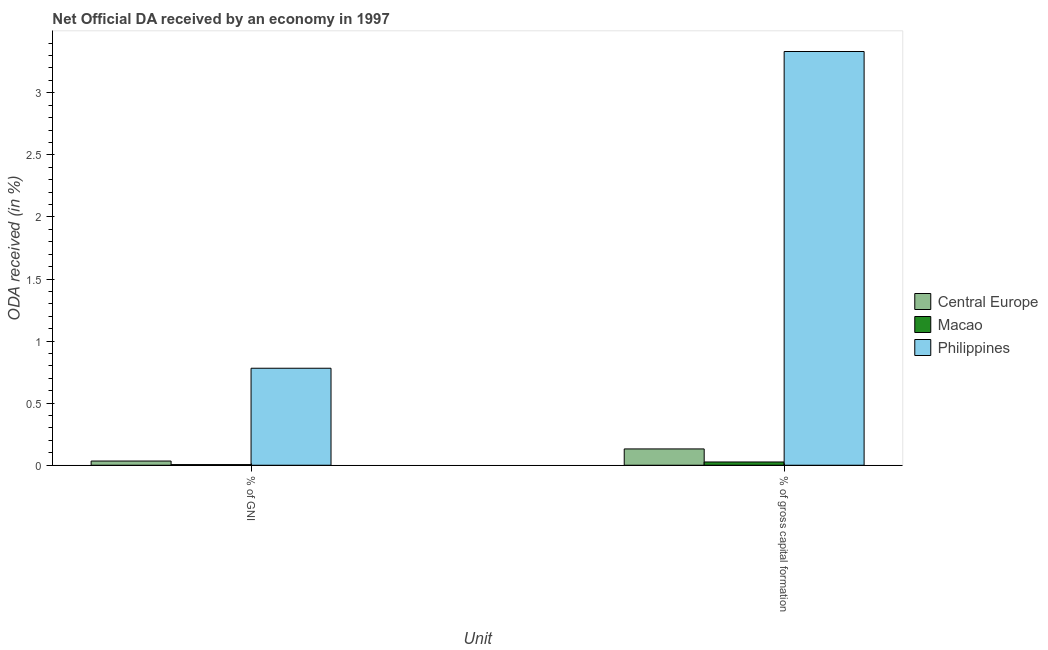How many different coloured bars are there?
Ensure brevity in your answer.  3. Are the number of bars per tick equal to the number of legend labels?
Offer a very short reply. Yes. Are the number of bars on each tick of the X-axis equal?
Offer a terse response. Yes. How many bars are there on the 2nd tick from the right?
Offer a terse response. 3. What is the label of the 1st group of bars from the left?
Keep it short and to the point. % of GNI. What is the oda received as percentage of gni in Philippines?
Provide a short and direct response. 0.78. Across all countries, what is the maximum oda received as percentage of gross capital formation?
Your answer should be compact. 3.33. Across all countries, what is the minimum oda received as percentage of gni?
Provide a short and direct response. 0.01. In which country was the oda received as percentage of gross capital formation maximum?
Make the answer very short. Philippines. In which country was the oda received as percentage of gni minimum?
Ensure brevity in your answer.  Macao. What is the total oda received as percentage of gni in the graph?
Provide a short and direct response. 0.82. What is the difference between the oda received as percentage of gross capital formation in Central Europe and that in Macao?
Your answer should be compact. 0.11. What is the difference between the oda received as percentage of gross capital formation in Central Europe and the oda received as percentage of gni in Philippines?
Your answer should be very brief. -0.65. What is the average oda received as percentage of gross capital formation per country?
Your answer should be very brief. 1.16. What is the difference between the oda received as percentage of gross capital formation and oda received as percentage of gni in Central Europe?
Provide a short and direct response. 0.1. What is the ratio of the oda received as percentage of gni in Macao to that in Philippines?
Your response must be concise. 0.01. Is the oda received as percentage of gross capital formation in Philippines less than that in Macao?
Your answer should be compact. No. What does the 1st bar from the left in % of gross capital formation represents?
Offer a terse response. Central Europe. What does the 1st bar from the right in % of GNI represents?
Offer a very short reply. Philippines. How many countries are there in the graph?
Provide a succinct answer. 3. What is the difference between two consecutive major ticks on the Y-axis?
Your answer should be compact. 0.5. Does the graph contain any zero values?
Keep it short and to the point. No. Where does the legend appear in the graph?
Make the answer very short. Center right. What is the title of the graph?
Your answer should be compact. Net Official DA received by an economy in 1997. Does "World" appear as one of the legend labels in the graph?
Keep it short and to the point. No. What is the label or title of the X-axis?
Offer a terse response. Unit. What is the label or title of the Y-axis?
Keep it short and to the point. ODA received (in %). What is the ODA received (in %) of Central Europe in % of GNI?
Give a very brief answer. 0.03. What is the ODA received (in %) of Macao in % of GNI?
Ensure brevity in your answer.  0.01. What is the ODA received (in %) in Philippines in % of GNI?
Your response must be concise. 0.78. What is the ODA received (in %) in Central Europe in % of gross capital formation?
Offer a terse response. 0.13. What is the ODA received (in %) in Macao in % of gross capital formation?
Ensure brevity in your answer.  0.03. What is the ODA received (in %) of Philippines in % of gross capital formation?
Your answer should be compact. 3.33. Across all Unit, what is the maximum ODA received (in %) in Central Europe?
Offer a very short reply. 0.13. Across all Unit, what is the maximum ODA received (in %) in Macao?
Give a very brief answer. 0.03. Across all Unit, what is the maximum ODA received (in %) in Philippines?
Your response must be concise. 3.33. Across all Unit, what is the minimum ODA received (in %) in Central Europe?
Give a very brief answer. 0.03. Across all Unit, what is the minimum ODA received (in %) in Macao?
Your answer should be very brief. 0.01. Across all Unit, what is the minimum ODA received (in %) of Philippines?
Provide a short and direct response. 0.78. What is the total ODA received (in %) in Central Europe in the graph?
Your answer should be compact. 0.17. What is the total ODA received (in %) of Macao in the graph?
Ensure brevity in your answer.  0.03. What is the total ODA received (in %) in Philippines in the graph?
Offer a terse response. 4.11. What is the difference between the ODA received (in %) in Central Europe in % of GNI and that in % of gross capital formation?
Your response must be concise. -0.1. What is the difference between the ODA received (in %) of Macao in % of GNI and that in % of gross capital formation?
Offer a terse response. -0.02. What is the difference between the ODA received (in %) of Philippines in % of GNI and that in % of gross capital formation?
Provide a short and direct response. -2.55. What is the difference between the ODA received (in %) in Central Europe in % of GNI and the ODA received (in %) in Macao in % of gross capital formation?
Your response must be concise. 0.01. What is the difference between the ODA received (in %) of Central Europe in % of GNI and the ODA received (in %) of Philippines in % of gross capital formation?
Provide a succinct answer. -3.3. What is the difference between the ODA received (in %) in Macao in % of GNI and the ODA received (in %) in Philippines in % of gross capital formation?
Offer a very short reply. -3.33. What is the average ODA received (in %) of Central Europe per Unit?
Give a very brief answer. 0.08. What is the average ODA received (in %) in Macao per Unit?
Provide a short and direct response. 0.02. What is the average ODA received (in %) in Philippines per Unit?
Ensure brevity in your answer.  2.06. What is the difference between the ODA received (in %) of Central Europe and ODA received (in %) of Macao in % of GNI?
Provide a succinct answer. 0.03. What is the difference between the ODA received (in %) in Central Europe and ODA received (in %) in Philippines in % of GNI?
Give a very brief answer. -0.75. What is the difference between the ODA received (in %) of Macao and ODA received (in %) of Philippines in % of GNI?
Your answer should be very brief. -0.78. What is the difference between the ODA received (in %) in Central Europe and ODA received (in %) in Macao in % of gross capital formation?
Provide a short and direct response. 0.11. What is the difference between the ODA received (in %) in Central Europe and ODA received (in %) in Philippines in % of gross capital formation?
Make the answer very short. -3.2. What is the difference between the ODA received (in %) in Macao and ODA received (in %) in Philippines in % of gross capital formation?
Your answer should be compact. -3.31. What is the ratio of the ODA received (in %) in Central Europe in % of GNI to that in % of gross capital formation?
Your answer should be compact. 0.26. What is the ratio of the ODA received (in %) in Macao in % of GNI to that in % of gross capital formation?
Make the answer very short. 0.2. What is the ratio of the ODA received (in %) in Philippines in % of GNI to that in % of gross capital formation?
Provide a succinct answer. 0.23. What is the difference between the highest and the second highest ODA received (in %) in Central Europe?
Give a very brief answer. 0.1. What is the difference between the highest and the second highest ODA received (in %) of Macao?
Ensure brevity in your answer.  0.02. What is the difference between the highest and the second highest ODA received (in %) in Philippines?
Provide a short and direct response. 2.55. What is the difference between the highest and the lowest ODA received (in %) in Central Europe?
Make the answer very short. 0.1. What is the difference between the highest and the lowest ODA received (in %) in Macao?
Offer a terse response. 0.02. What is the difference between the highest and the lowest ODA received (in %) of Philippines?
Provide a short and direct response. 2.55. 